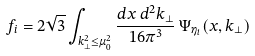<formula> <loc_0><loc_0><loc_500><loc_500>f _ { i } = 2 \sqrt { 3 } \int _ { k _ { \perp } ^ { 2 } \leq \mu _ { 0 } ^ { 2 } } \frac { d x \, d ^ { 2 } k _ { \perp } } { 1 6 \pi ^ { 3 } } \, \Psi _ { \eta _ { i } } ( x , k _ { \perp } )</formula> 